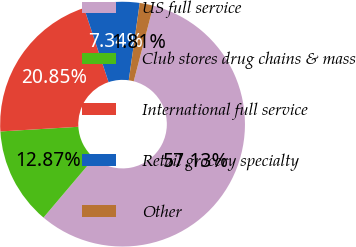Convert chart. <chart><loc_0><loc_0><loc_500><loc_500><pie_chart><fcel>US full service<fcel>Club stores drug chains & mass<fcel>International full service<fcel>Retail grocery specialty<fcel>Other<nl><fcel>57.12%<fcel>12.87%<fcel>20.85%<fcel>7.34%<fcel>1.81%<nl></chart> 